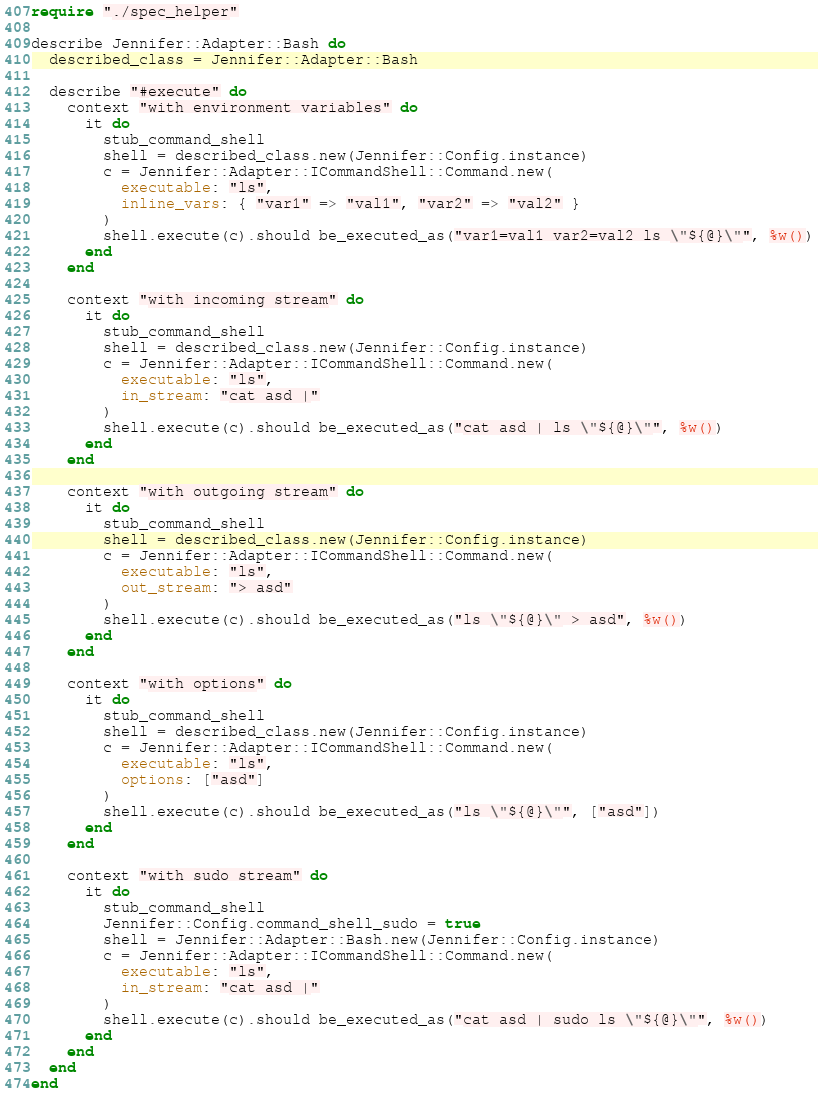<code> <loc_0><loc_0><loc_500><loc_500><_Crystal_>require "./spec_helper"

describe Jennifer::Adapter::Bash do
  described_class = Jennifer::Adapter::Bash

  describe "#execute" do
    context "with environment variables" do
      it do
        stub_command_shell
        shell = described_class.new(Jennifer::Config.instance)
        c = Jennifer::Adapter::ICommandShell::Command.new(
          executable: "ls",
          inline_vars: { "var1" => "val1", "var2" => "val2" }
        )
        shell.execute(c).should be_executed_as("var1=val1 var2=val2 ls \"${@}\"", %w())
      end
    end

    context "with incoming stream" do
      it do
        stub_command_shell
        shell = described_class.new(Jennifer::Config.instance)
        c = Jennifer::Adapter::ICommandShell::Command.new(
          executable: "ls",
          in_stream: "cat asd |"
        )
        shell.execute(c).should be_executed_as("cat asd | ls \"${@}\"", %w())
      end
    end

    context "with outgoing stream" do
      it do
        stub_command_shell
        shell = described_class.new(Jennifer::Config.instance)
        c = Jennifer::Adapter::ICommandShell::Command.new(
          executable: "ls",
          out_stream: "> asd"
        )
        shell.execute(c).should be_executed_as("ls \"${@}\" > asd", %w())
      end
    end

    context "with options" do
      it do
        stub_command_shell
        shell = described_class.new(Jennifer::Config.instance)
        c = Jennifer::Adapter::ICommandShell::Command.new(
          executable: "ls",
          options: ["asd"]
        )
        shell.execute(c).should be_executed_as("ls \"${@}\"", ["asd"])
      end
    end

    context "with sudo stream" do
      it do
        stub_command_shell
        Jennifer::Config.command_shell_sudo = true
        shell = Jennifer::Adapter::Bash.new(Jennifer::Config.instance)
        c = Jennifer::Adapter::ICommandShell::Command.new(
          executable: "ls",
          in_stream: "cat asd |"
        )
        shell.execute(c).should be_executed_as("cat asd | sudo ls \"${@}\"", %w())
      end
    end
  end
end
</code> 